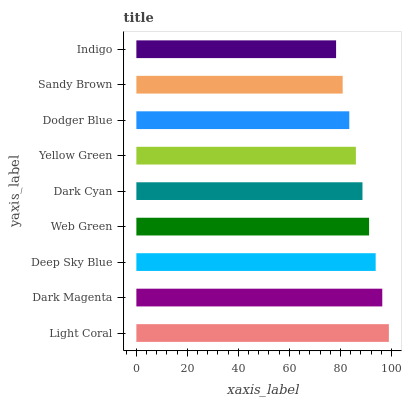Is Indigo the minimum?
Answer yes or no. Yes. Is Light Coral the maximum?
Answer yes or no. Yes. Is Dark Magenta the minimum?
Answer yes or no. No. Is Dark Magenta the maximum?
Answer yes or no. No. Is Light Coral greater than Dark Magenta?
Answer yes or no. Yes. Is Dark Magenta less than Light Coral?
Answer yes or no. Yes. Is Dark Magenta greater than Light Coral?
Answer yes or no. No. Is Light Coral less than Dark Magenta?
Answer yes or no. No. Is Dark Cyan the high median?
Answer yes or no. Yes. Is Dark Cyan the low median?
Answer yes or no. Yes. Is Yellow Green the high median?
Answer yes or no. No. Is Light Coral the low median?
Answer yes or no. No. 